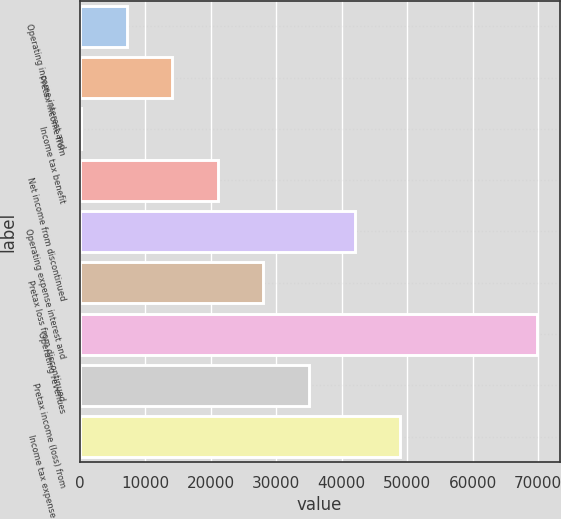Convert chart to OTSL. <chart><loc_0><loc_0><loc_500><loc_500><bar_chart><fcel>Operating income interest and<fcel>Pretax income from<fcel>Income tax benefit<fcel>Net income from discontinued<fcel>Operating expense interest and<fcel>Pretax loss from discontinued<fcel>Operating revenues<fcel>Pretax income (loss) from<fcel>Income tax expense (benefit)<nl><fcel>7213.4<fcel>14165.8<fcel>261<fcel>21118.2<fcel>41975.4<fcel>28070.6<fcel>69785<fcel>35023<fcel>48927.8<nl></chart> 